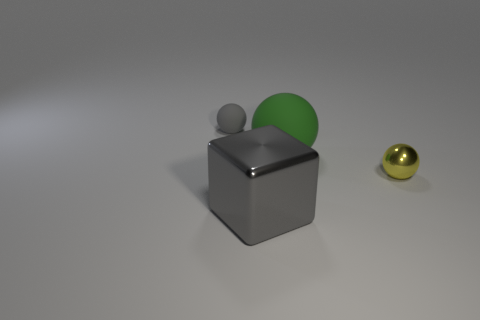Subtract all rubber spheres. How many spheres are left? 1 Subtract all gray balls. How many balls are left? 2 Add 3 tiny spheres. How many objects exist? 7 Subtract all cubes. How many objects are left? 3 Subtract 3 balls. How many balls are left? 0 Add 1 small gray rubber objects. How many small gray rubber objects exist? 2 Subtract 0 yellow cylinders. How many objects are left? 4 Subtract all red spheres. Subtract all brown cubes. How many spheres are left? 3 Subtract all brown matte things. Subtract all big green things. How many objects are left? 3 Add 1 big metal objects. How many big metal objects are left? 2 